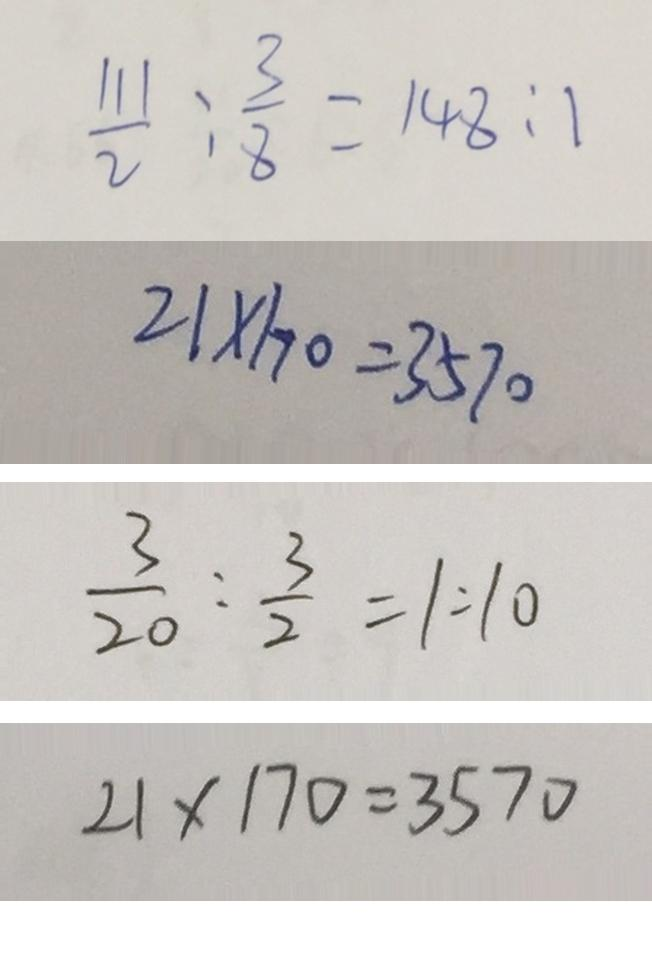<formula> <loc_0><loc_0><loc_500><loc_500>\frac { 1 1 1 } { 2 } : \frac { 3 } { 8 } = 1 4 8 : 1 
 2 1 \times 1 7 0 = 3 5 7 0 
 \frac { 3 } { 2 0 } : \frac { 3 } { 2 } = 1 : 1 0 
 2 1 \times 1 7 0 = 3 5 7 0</formula> 